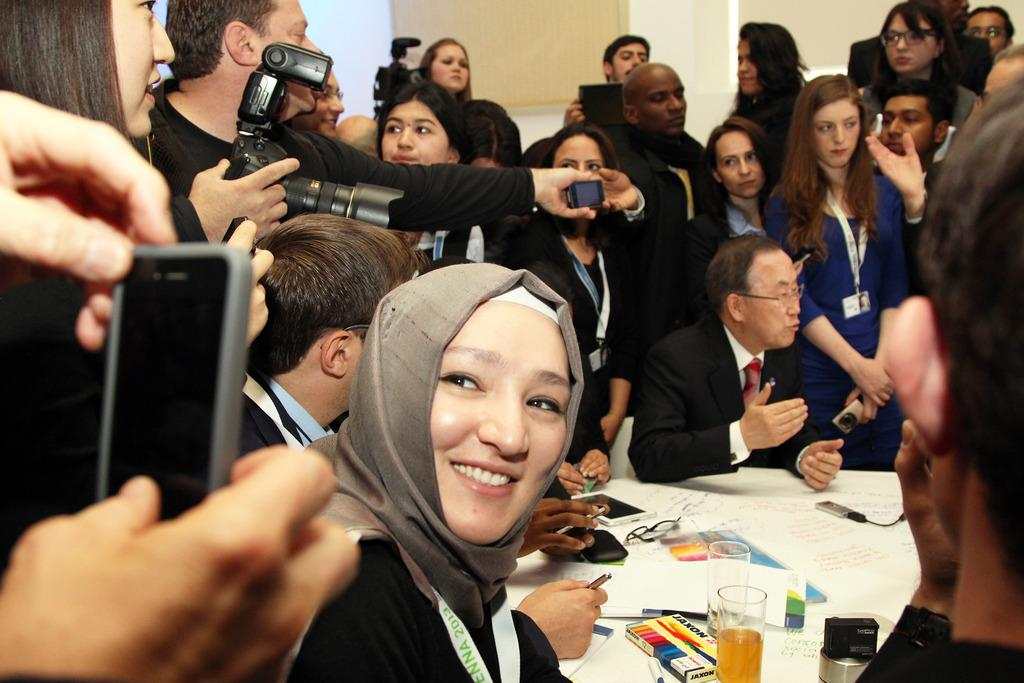How many people are in the image? There are many people in the image. What color are the clothes worn by the people in the image? The people are dressed in black. What are some people doing in the image? Some people are sitting on a white table. What are the reporters doing in the image? The reporters are taking snaps using cameras and mobile phones. What degree of growth can be observed in the scene? There is no information about growth or development in the image, as it primarily features people dressed in black and reporters taking snaps. 